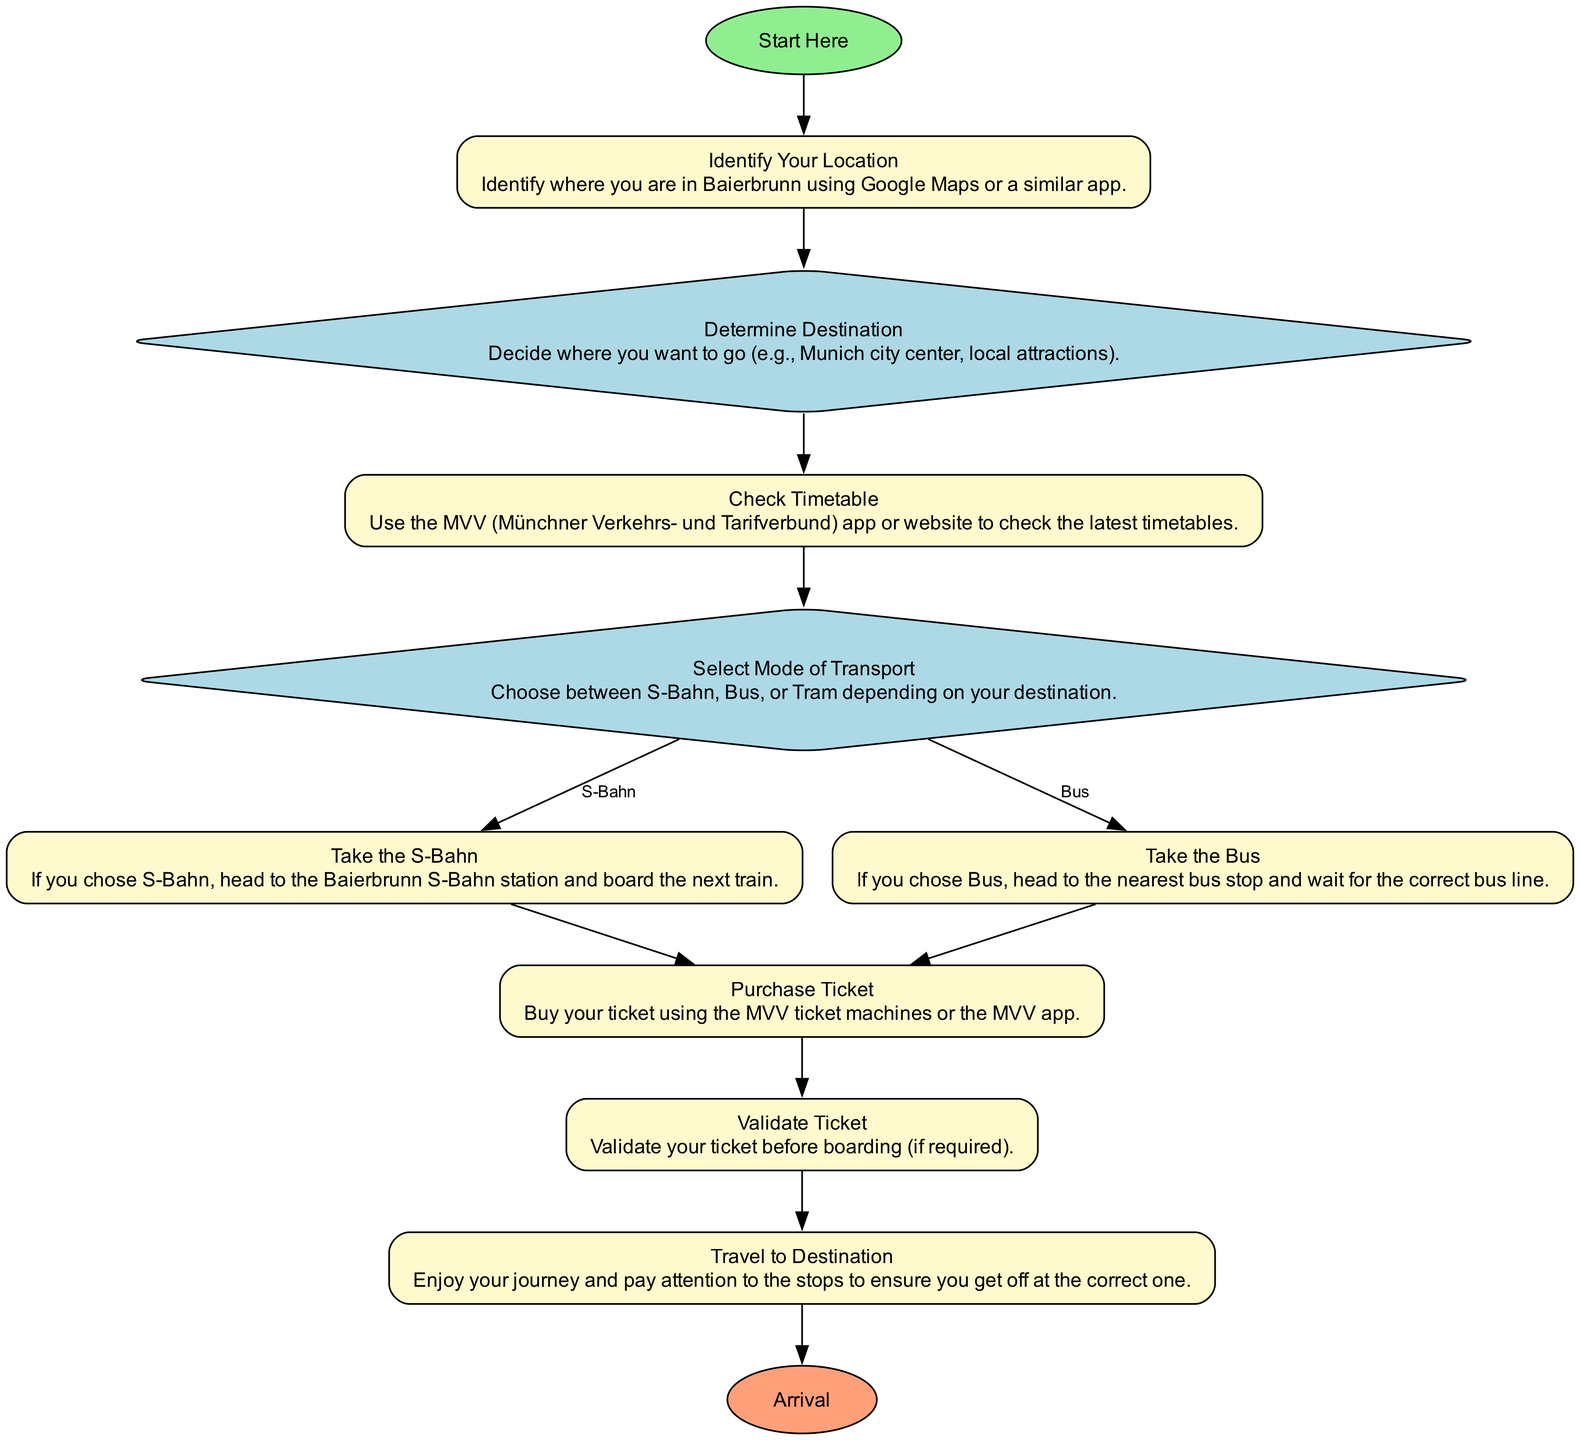What is the first step in using public transportation in Baierbrunn? The first step is labeled as "Start Here," indicating the beginning of the process for using public transportation.
Answer: Start Here How many decision nodes are in the diagram? The diagram contains two decision nodes: "Determine Destination" and "Select Mode of Transport." These nodes require choices to be made before proceeding.
Answer: 2 What are the two modes of transport options available after selecting the mode? After selecting a mode of transport, the options are "S-Bahn" and "Bus," which are specified as choices leading to different actions in the flow.
Answer: S-Bahn, Bus What should you do if you choose to take the Bus? If you choose to take the Bus, you need to head to the nearest bus stop and wait for the correct bus line, according to the action described in the flow chart.
Answer: Head to the nearest bus stop What is required before boarding the transport? You need to validate your ticket before boarding, which is a specific action mentioned in the flow of the diagram.
Answer: Validate your ticket If someone decides to travel to the Munich city center, which mode of transport do they likely choose? Given that "Munich city center" is a common destination from Baierbrunn, the logical choice of transport would likely be the "S-Bahn," as it typically connects suburban areas to city centers efficiently.
Answer: S-Bahn What is the final step in the public transportation process? The final step in this process is "Arrival," indicating that you have reached your destination and can begin your adventure based on the successful use of public transportation.
Answer: Arrival How do you check the latest timetables? The latest timetables can be checked using the MVV app or website, as specified in the action "Check Timetable."
Answer: MVV app or website 